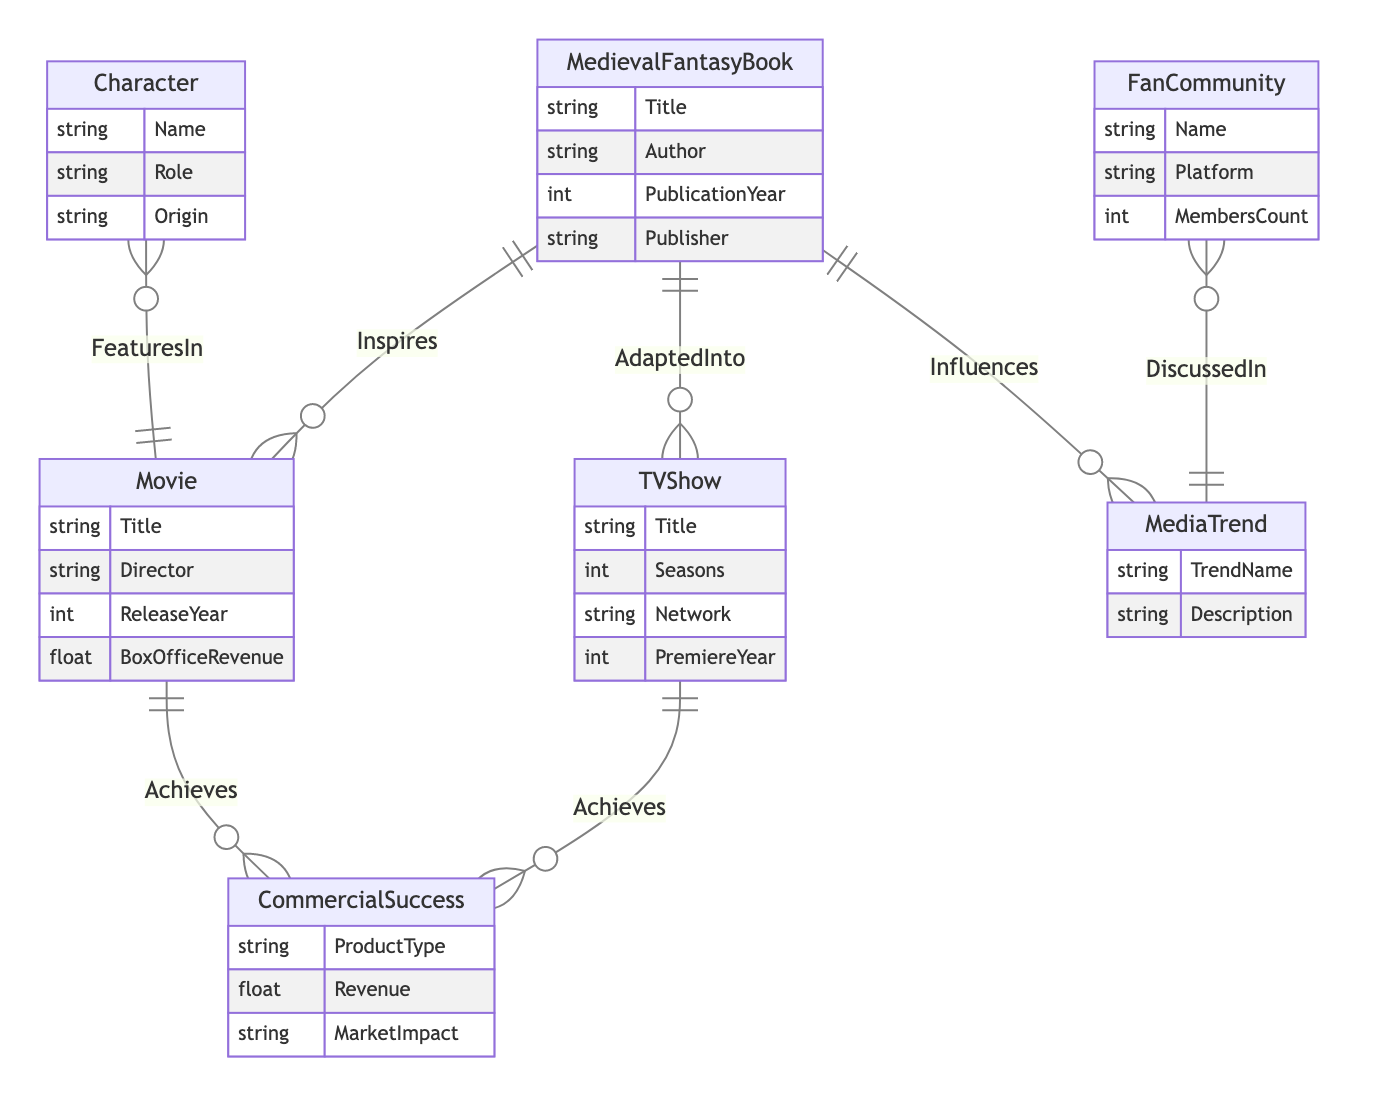What entities represent adaptations of medieval fantasy books? The diagram shows that both Movies and TV Shows are connected to the MedievalFantasyBook entity through the AdaptedInto relationship.
Answer: Movies, TV Shows How many relationships are depicted in the diagram? By counting the relationships between entities, there are a total of six distinct relationships shown in the diagram: Inspires, AdaptedInto, Influences, FeaturesIn, DiscussedIn, and Achieves.
Answer: 6 Which entity is related to both Movies and CommercialSuccess? The diagram indicates that the Movie entity is connected to the CommercialSuccess entity through the Achieves relationship, implying that movies can achieve commercial success.
Answer: Movie What is the role of the Character in the diagram? The Character entity is linked to the Movie entity through the FeaturesIn relationship, demonstrating that characters from medieval fantasy literature appear in movies.
Answer: FeaturesIn How do FanCommunities relate to MediaTrends? The relationship between FanCommunity and MediaTrend is described as DiscussedIn, showing that fan communities engage in discussions about various media trends within the context of medieval fantasy.
Answer: DiscussedIn Which two entities have an influence relationship? The diagram illustrates that the MedievalFantasyBook and MediaTrend entities are connected through the Influences relationship, signifying that medieval fantasy literature impacts media trends.
Answer: MedievalFantasyBook, MediaTrend What type of revenue information is associated with CommercialSuccess? The CommercialSuccess entity includes attributes related to revenue such as Revenue and MarketImpact, which detail the financial success and broader impact of successful products.
Answer: Revenue, MarketImpact How many attributes does the TVShow entity have? The TVShow entity contains four attributes: Title, Seasons, Network, and PremiereYear, reflecting information specific to television series.
Answer: 4 Which entity describes the characteristics of various trends? The MediaTrend entity is dedicated to describing trends, as it includes attributes such as TrendName and Description, detailing the nature and impact of these trends in modern society.
Answer: MediaTrend 